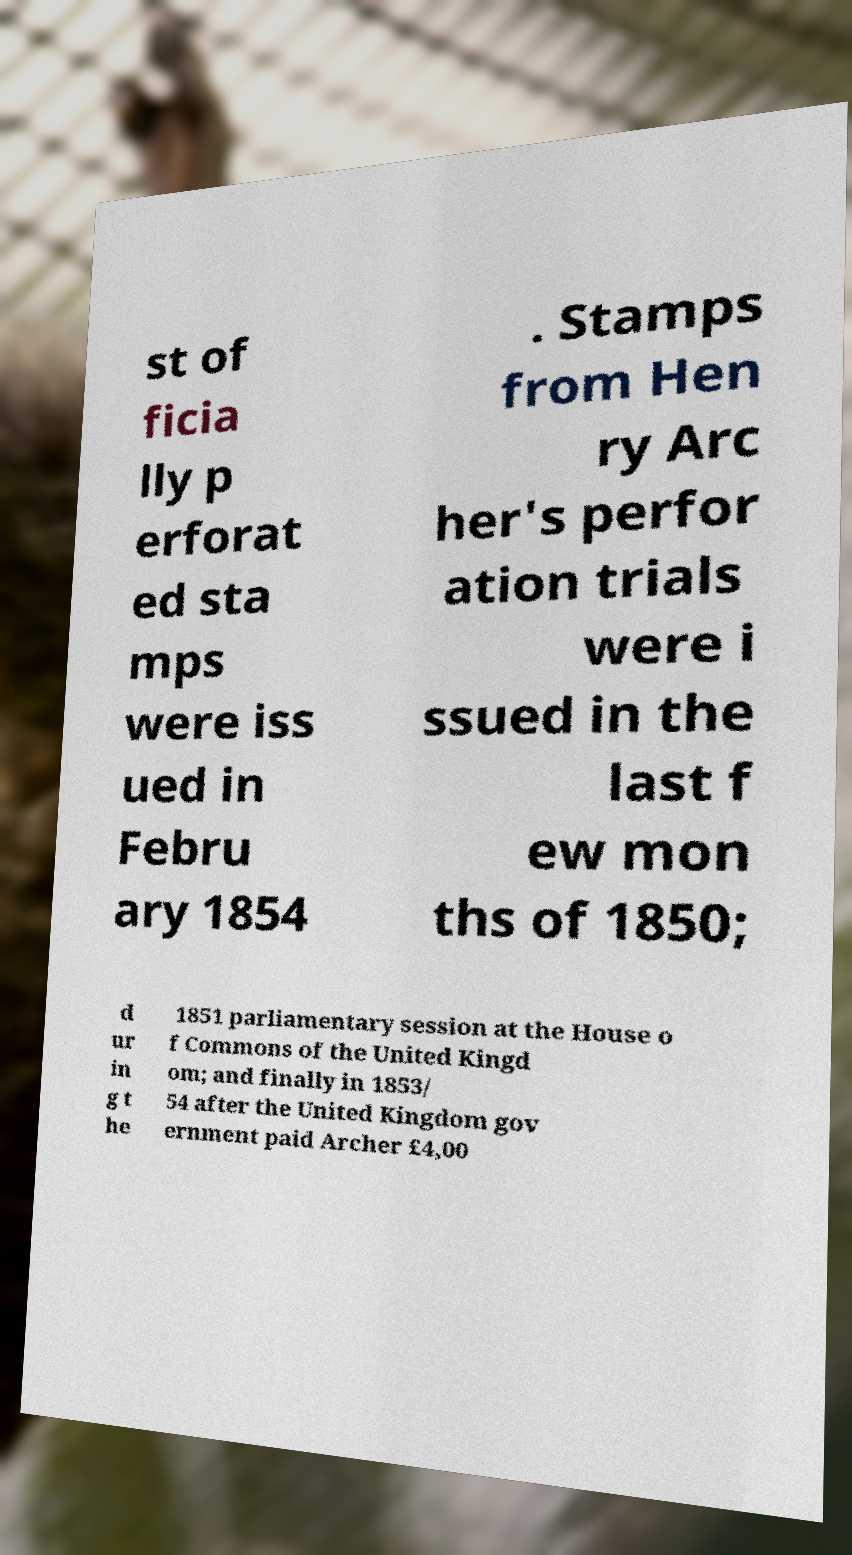Could you assist in decoding the text presented in this image and type it out clearly? st of ficia lly p erforat ed sta mps were iss ued in Febru ary 1854 . Stamps from Hen ry Arc her's perfor ation trials were i ssued in the last f ew mon ths of 1850; d ur in g t he 1851 parliamentary session at the House o f Commons of the United Kingd om; and finally in 1853/ 54 after the United Kingdom gov ernment paid Archer £4,00 